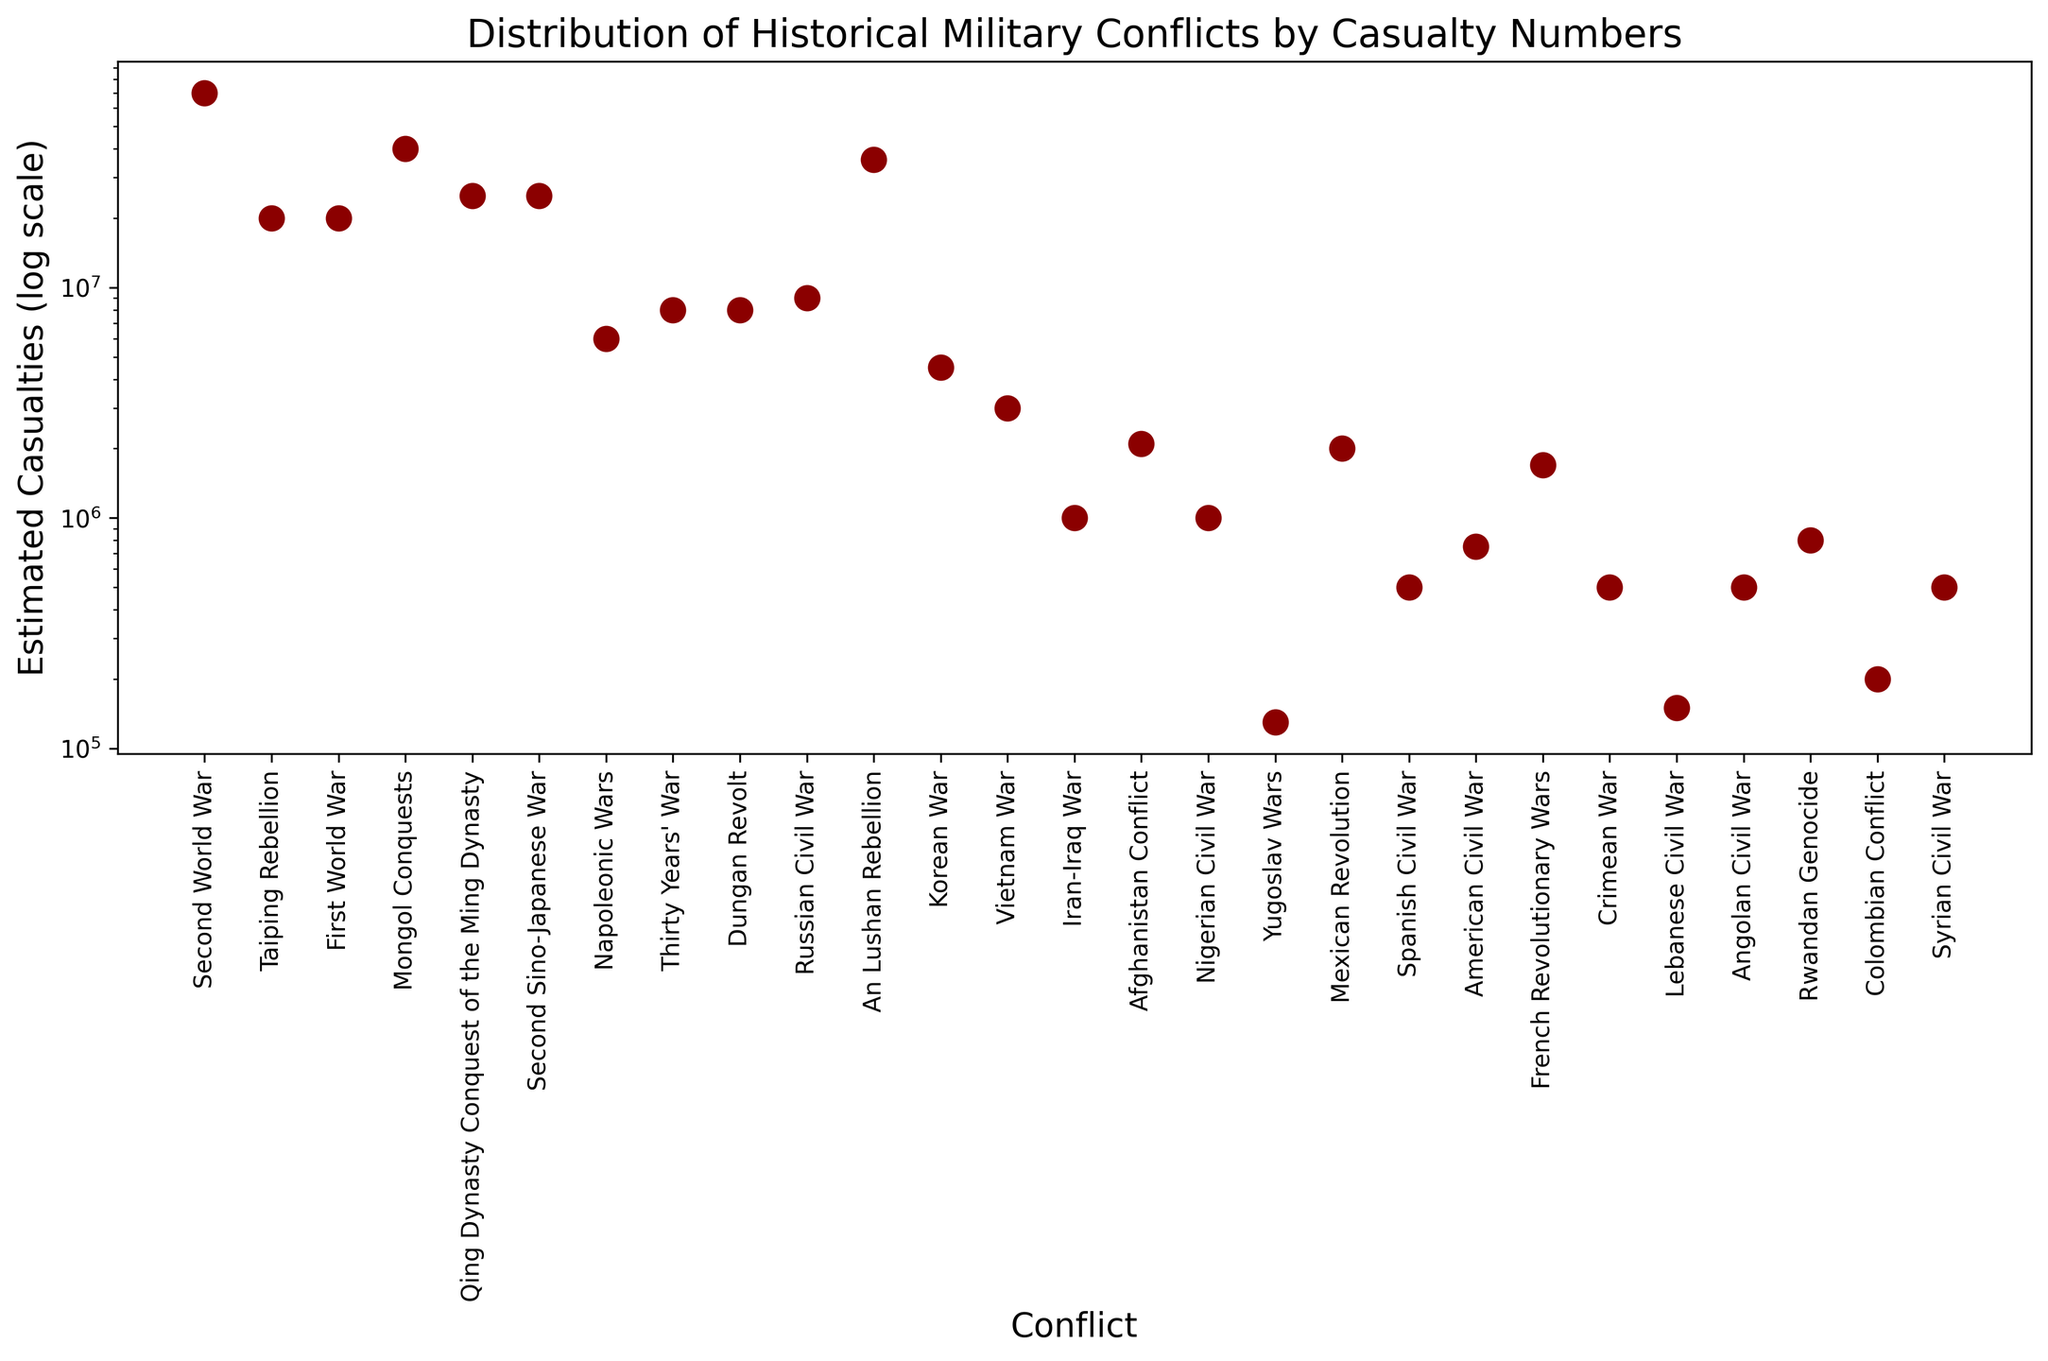What is the estimated number of casualties for the Second World War? The Second World War has a y-axis value. By locating the relevant point in the figure and considering the log scale, we can find the estimated number of casualties.
Answer: 70,000,000 Which conflict had fewer estimated casualties: the Vietnam War or the Russian Civil War? Compare the y-axis positions of the points representing the Vietnam War and the Russian Civil War. The point lower on the y-axis corresponds to fewer casualties.
Answer: Vietnam War Which conflict had the highest estimated casualties? Identify the point at the top of the y-axis on the log scale, which represents the conflict with the highest estimated casualties.
Answer: Second World War Which conflict had a higher estimated casualty count: the Taiping Rebellion or the First World War? Compare the positions of the Taiping Rebellion and the First World War on the y-axis. The higher point on the log scale has more casualties.
Answer: Taiping Rebellion What is the range of estimated casualties for the conflicts shown in the figure? Identify the lowest and highest points on the y-axis and calculate the difference in their values. The range is from the smallest to the largest estimate of casualties.
Answer: 130,000 to 70,000,000 How many conflicts have estimated casualties between 1,000,000 and 10,000,000? Count the points that fall within the y-axis range between 1,000,000 and 10,000,000 on the log scale.
Answer: 8 Which conflict had similar estimated casualties to the American Civil War? Locate the point that corresponds to the American Civil War and find any other points at a similar position on the y-axis.
Answer: Crimean War What is the estimated number of casualties for the conflicts that occurred in the 20th century with more than 5,000,000 casualties? Identify points in the 20th century on the x-axis and check if their y-axis position exceeds 5,000,000 on the log scale, listing these conflicts.
Answer: Second World War, First World War, Second Sino-Japanese War, Russian Civil War How do the estimated casualties of the Korean War compare to the estimated casualties of the Vietnam War? Compare the y-axis positions of the Korean War and Vietnam War points. The higher point indicates more casualties.
Answer: Korean War has more What characteristic distinguishes the point representing the An Lushan Rebellion from most other conflicts? Analyze the appearance and position of the point for the An Lushan Rebellion. It stands out due to its higher casualty number on the log scale.
Answer: Highest casualties before the 20th century 